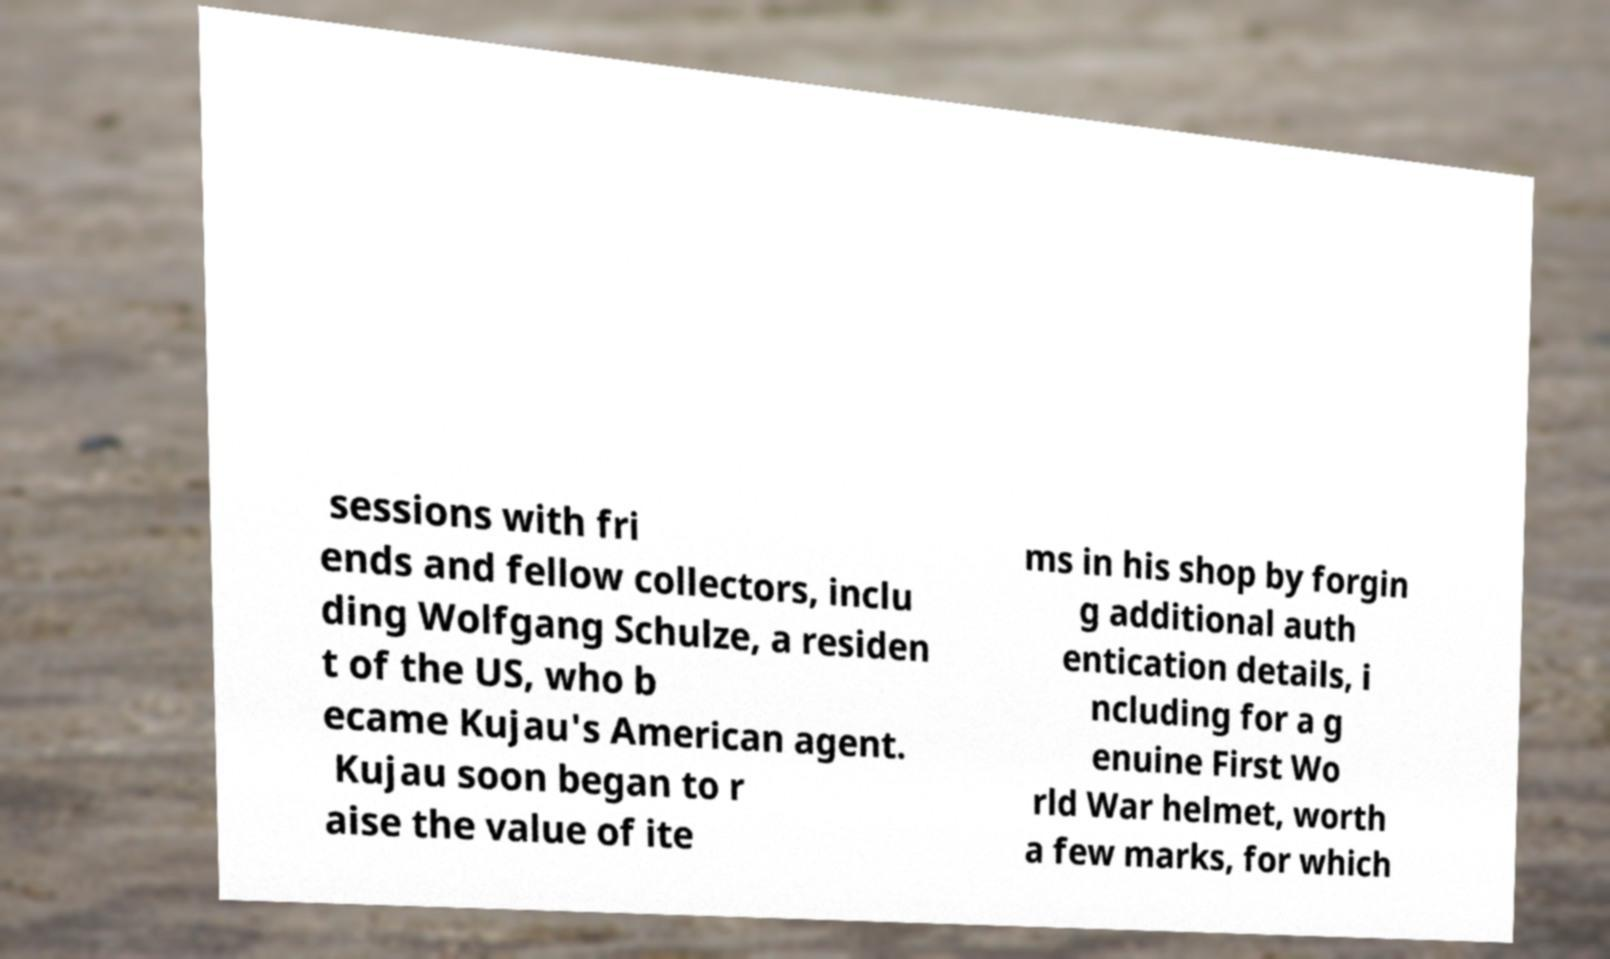Could you assist in decoding the text presented in this image and type it out clearly? sessions with fri ends and fellow collectors, inclu ding Wolfgang Schulze, a residen t of the US, who b ecame Kujau's American agent. Kujau soon began to r aise the value of ite ms in his shop by forgin g additional auth entication details, i ncluding for a g enuine First Wo rld War helmet, worth a few marks, for which 